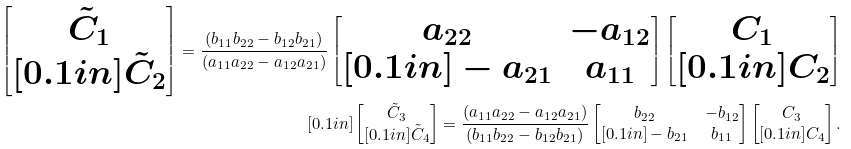<formula> <loc_0><loc_0><loc_500><loc_500>\begin{bmatrix} \tilde { C } _ { 1 } \\ [ 0 . 1 i n ] \tilde { C } _ { 2 } \end{bmatrix} = \frac { ( b _ { 1 1 } b _ { 2 2 } - b _ { 1 2 } b _ { 2 1 } ) } { ( a _ { 1 1 } a _ { 2 2 } - a _ { 1 2 } a _ { 2 1 } ) } \begin{bmatrix} a _ { 2 2 } & - a _ { 1 2 } \\ [ 0 . 1 i n ] - a _ { 2 1 } & a _ { 1 1 } \end{bmatrix} \begin{bmatrix} C _ { 1 } \\ [ 0 . 1 i n ] C _ { 2 } \end{bmatrix} \\ [ 0 . 1 i n ] \begin{bmatrix} \tilde { C } _ { 3 } \\ [ 0 . 1 i n ] \tilde { C } _ { 4 } \end{bmatrix} = \frac { ( a _ { 1 1 } a _ { 2 2 } - a _ { 1 2 } a _ { 2 1 } ) } { ( b _ { 1 1 } b _ { 2 2 } - b _ { 1 2 } b _ { 2 1 } ) } \begin{bmatrix} b _ { 2 2 } & - b _ { 1 2 } \\ [ 0 . 1 i n ] - b _ { 2 1 } & b _ { 1 1 } \end{bmatrix} \begin{bmatrix} C _ { 3 } \\ [ 0 . 1 i n ] C _ { 4 } \end{bmatrix} .</formula> 